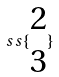<formula> <loc_0><loc_0><loc_500><loc_500>s s \{ \begin{matrix} 2 \\ 3 \end{matrix} \}</formula> 